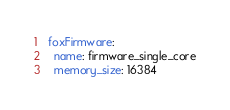Convert code to text. <code><loc_0><loc_0><loc_500><loc_500><_YAML_>foxFirmware:
  name: firmware_single_core
  memory_size: 16384
</code> 